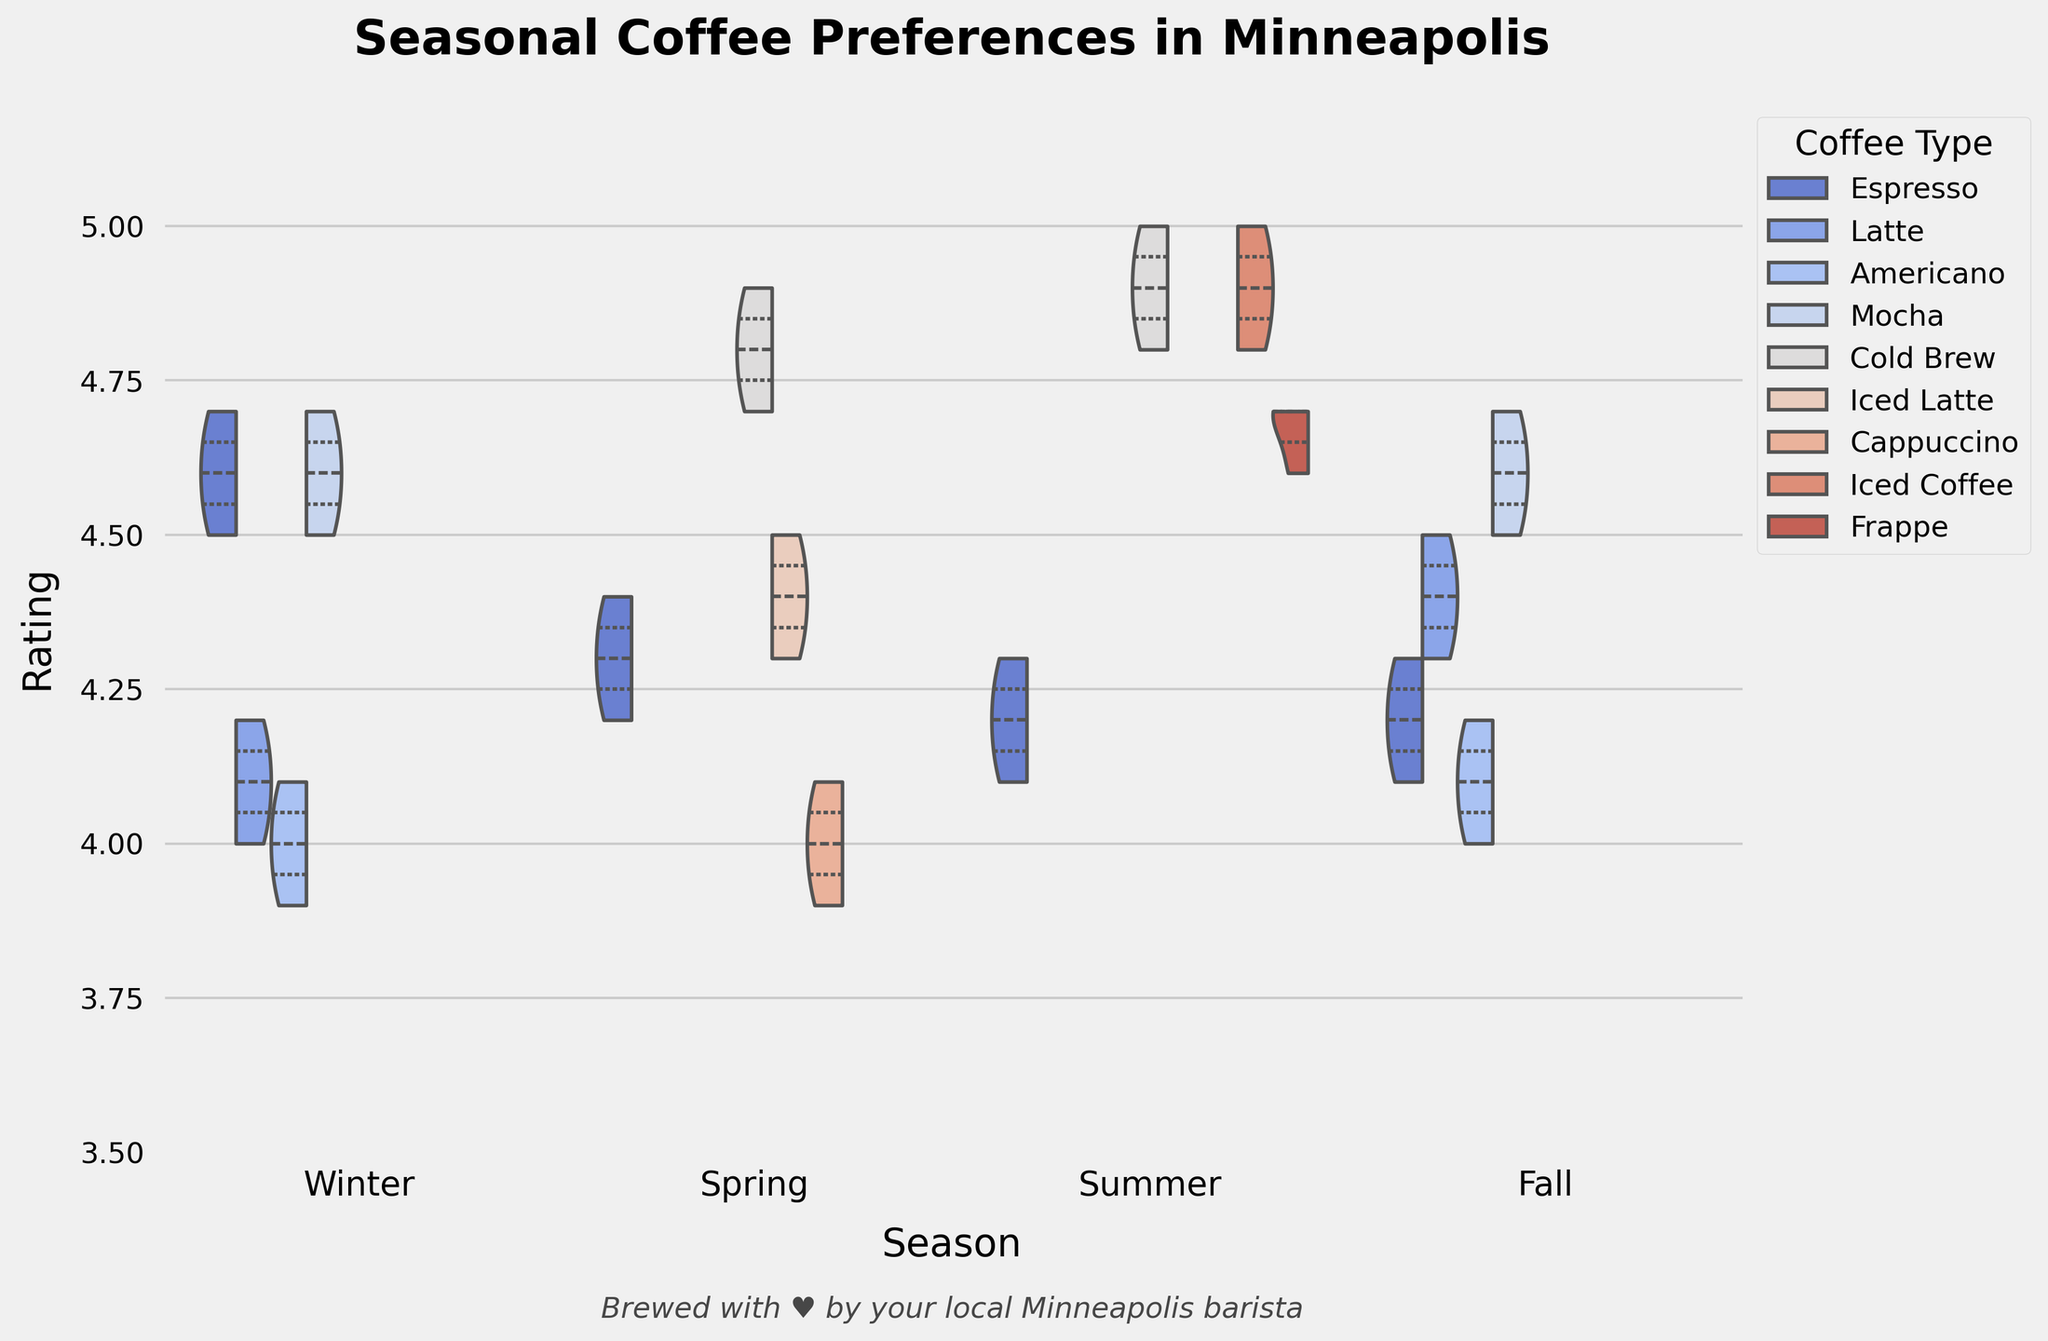What's the highest-rated coffee type in Winter? By looking at the highest points in the Winter season section, we can see the highest-rated coffee type is Espresso with a rating of 4.7
Answer: Espresso Which coffee type has the smallest interquartile range in Spring? Observing the violin plots for Spring, the Espresso plot has the smallest interquartile range, indicated by the narrowest central distribution
Answer: Espresso How does the median rating of Cold Brew compare between Spring and Summer? The violins for Cold Brew show that the median is slightly higher in Summer compared to Spring, denoted by the wider upper section in Summer
Answer: Higher in Summer What is the range of Mocha ratings in Fall? The Mocha violin plot in Fall extends from 4.5 to 4.7, representing the range
Answer: 4.5-4.7 Which season shows the highest preference for Iced Coffee? Look at the peaks of the Iced Coffee plot across the seasons, the highest ratings and preferences occur in Summer
Answer: Summer What's the lowest rating given to any coffee type in Winter? The lowest end of the violin plots in Winter indicates a rating of 3.9 for Americano
Answer: 3.9 Which coffee type seems to be most consistently rated across all seasons? Observing the plots, Espresso has a comparatively consistent distribution across all seasons without drastic changes in shape
Answer: Espresso Which season has the largest variety of coffee types? By counting the different colors in each seasonal section, Spring, Fall, and Winter have four types, while Summer has three
Answer: Spring, Fall, Winter (tie) Comparing Winter and Fall, which season has a higher average rating for Mocha? Both Winter and Fall show high median ratings for Mocha, but Winter appears to have a slightly higher concentrated area around 4.6
Answer: Winter How does the average rating for Lattes in Winter compare to Fall? Both seasons show similar average ratings, but Fall Latte violins are slightly higher than those in Winter
Answer: Fall 